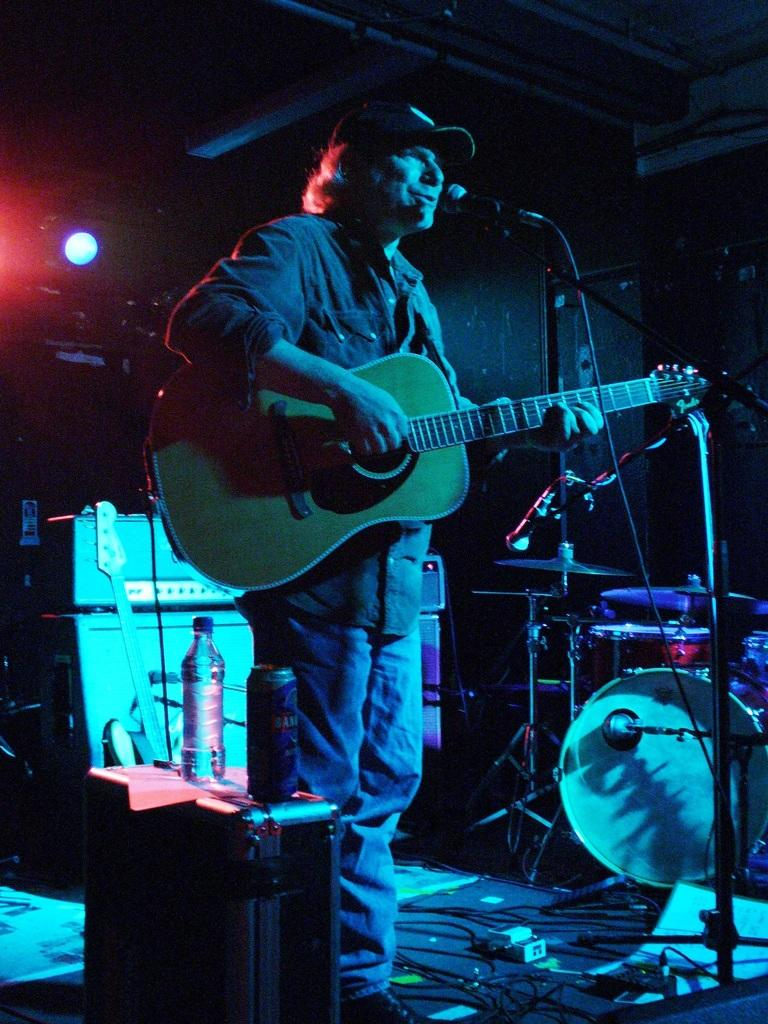What is the man in the image doing? The man is standing in the image and holding a guitar in his hand. What object is in front of the man? There is a microphone in front of the man. What can be seen in the background of the image? Musical instruments are visible in the background of the image. How many horses can be seen playing with a toy in the image? There are no horses or toys present in the image. 